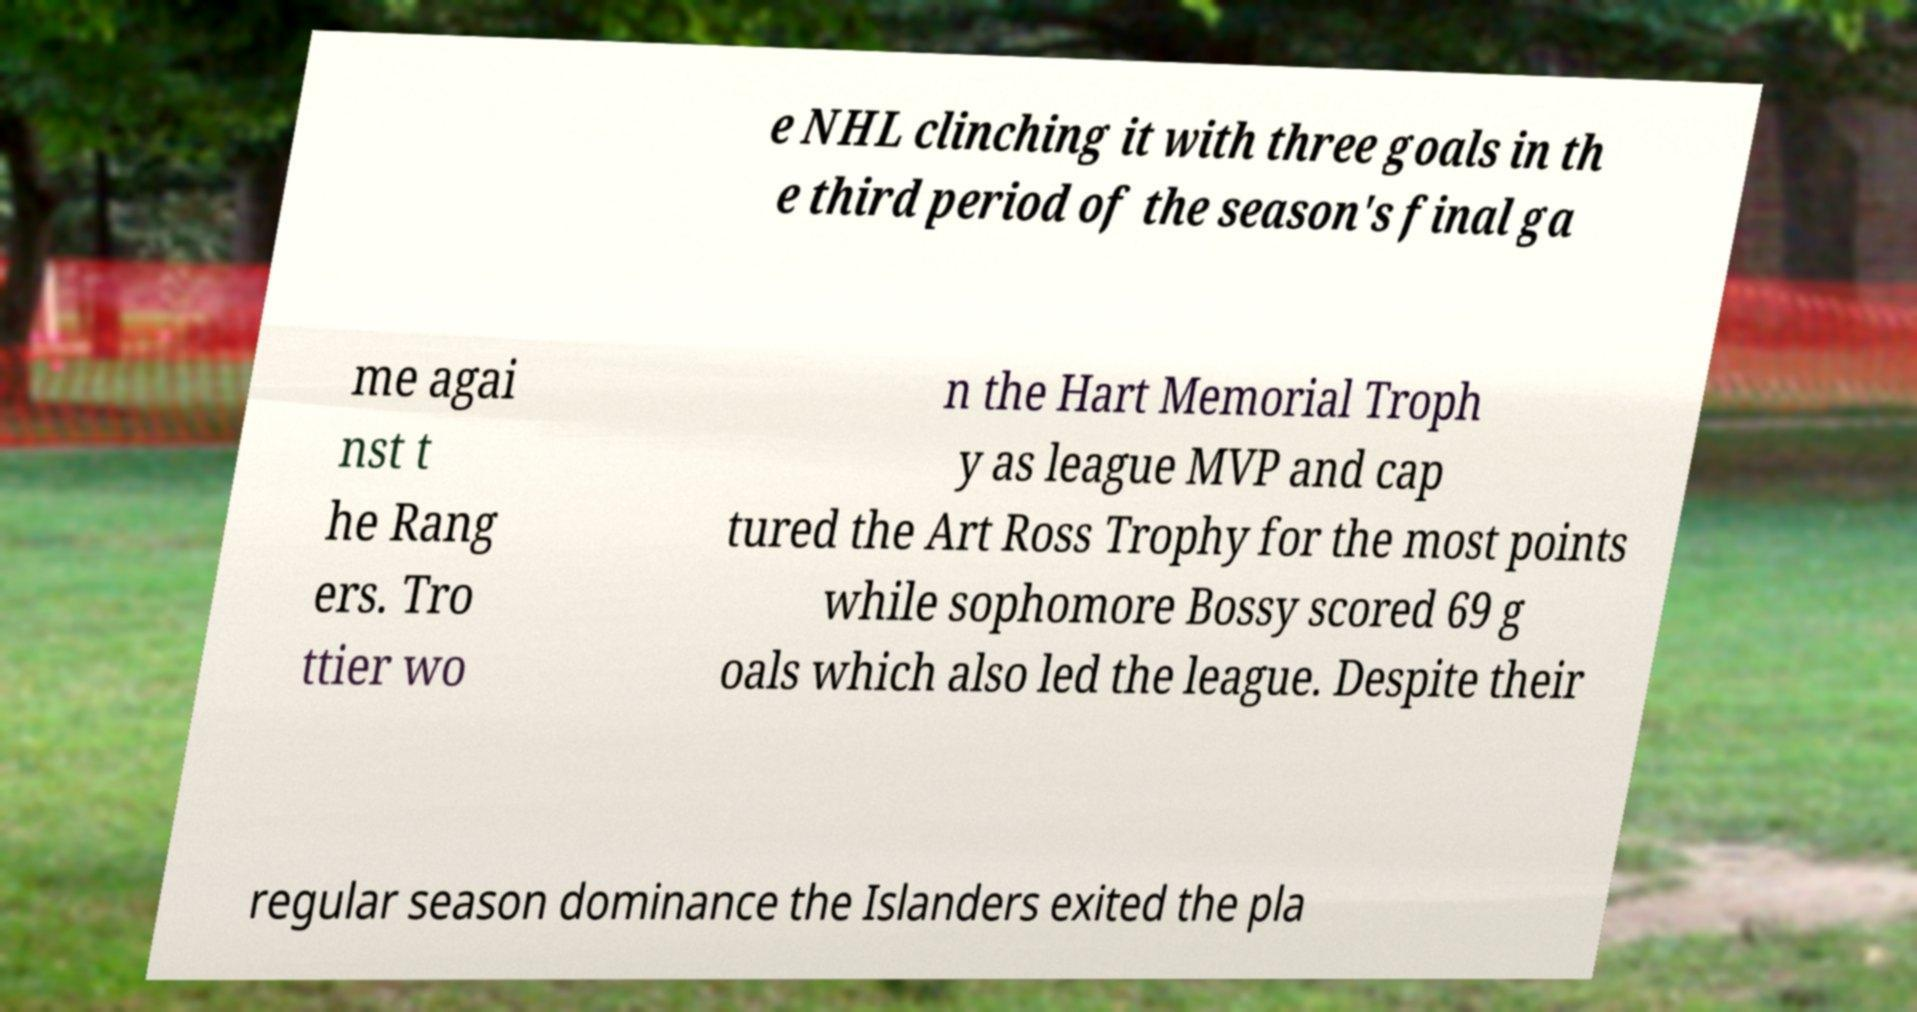What messages or text are displayed in this image? I need them in a readable, typed format. e NHL clinching it with three goals in th e third period of the season's final ga me agai nst t he Rang ers. Tro ttier wo n the Hart Memorial Troph y as league MVP and cap tured the Art Ross Trophy for the most points while sophomore Bossy scored 69 g oals which also led the league. Despite their regular season dominance the Islanders exited the pla 